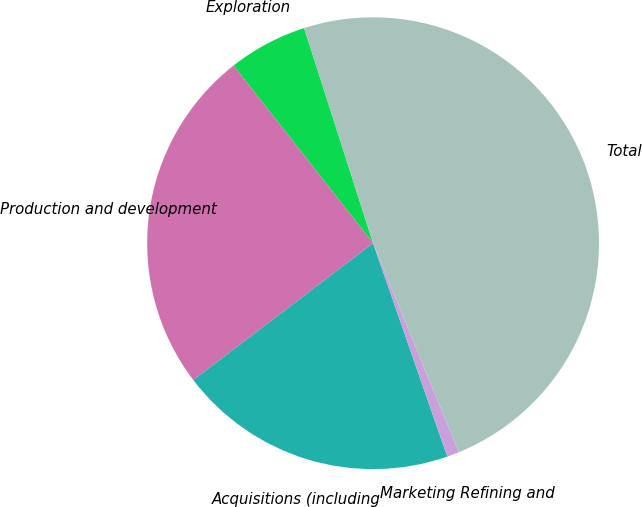Convert chart. <chart><loc_0><loc_0><loc_500><loc_500><pie_chart><fcel>Exploration<fcel>Production and development<fcel>Acquisitions (including<fcel>Marketing Refining and<fcel>Total<nl><fcel>5.66%<fcel>24.76%<fcel>19.97%<fcel>0.87%<fcel>48.74%<nl></chart> 